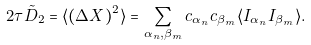Convert formula to latex. <formula><loc_0><loc_0><loc_500><loc_500>2 \tau \tilde { D } _ { 2 } = \langle ( \Delta X ) ^ { 2 } \rangle = \sum _ { \alpha _ { n } , \beta _ { m } } c _ { \alpha _ { n } } c _ { \beta _ { m } } \langle I _ { \alpha _ { n } } I _ { \beta _ { m } } \rangle .</formula> 